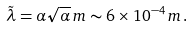<formula> <loc_0><loc_0><loc_500><loc_500>\tilde { \lambda } = \alpha \sqrt { \alpha } \, m \sim 6 \times 1 0 ^ { - 4 } \, m \, .</formula> 